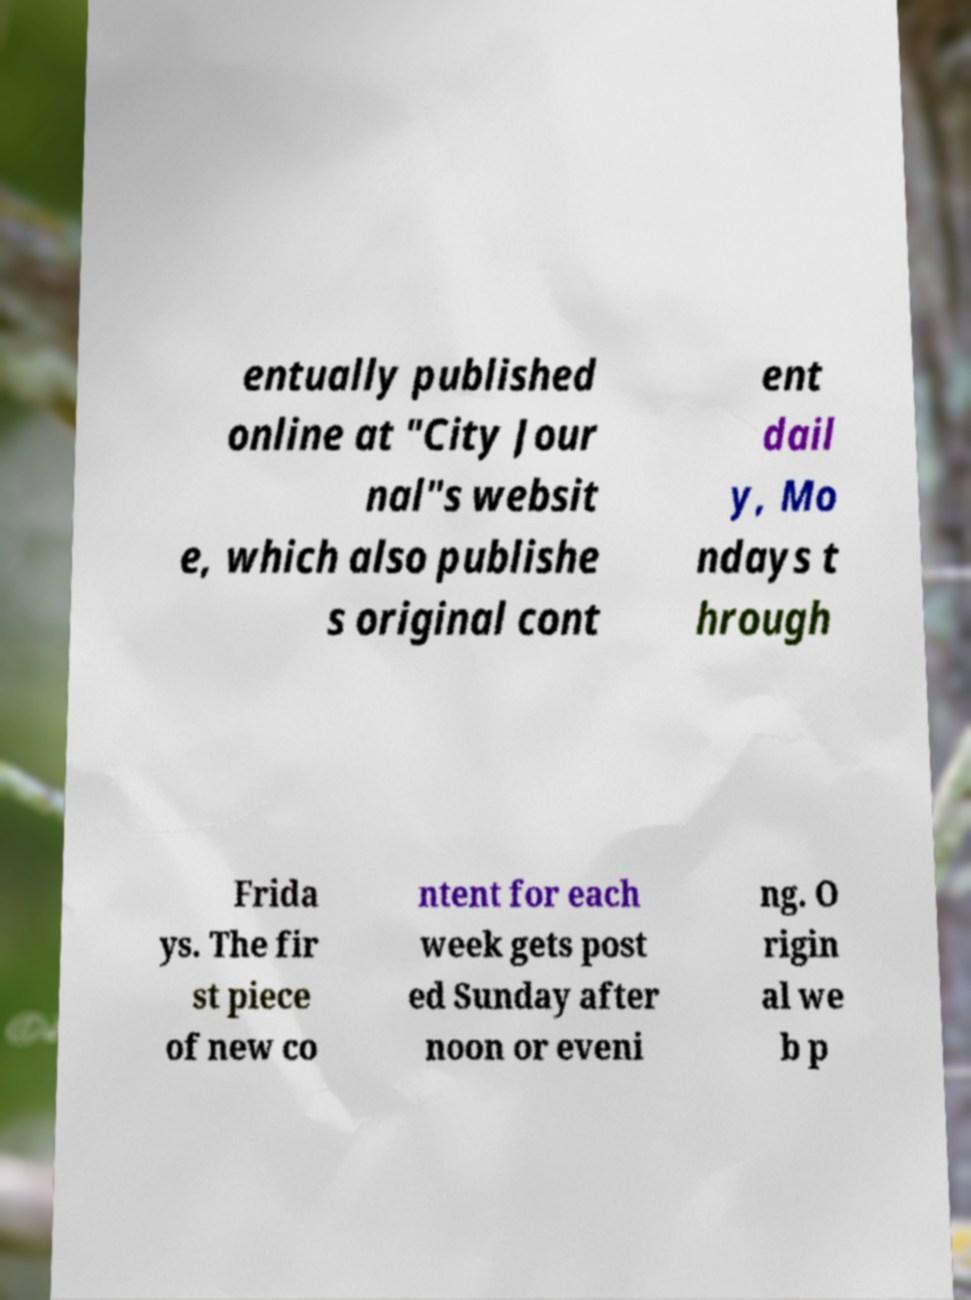Can you accurately transcribe the text from the provided image for me? entually published online at "City Jour nal"s websit e, which also publishe s original cont ent dail y, Mo ndays t hrough Frida ys. The fir st piece of new co ntent for each week gets post ed Sunday after noon or eveni ng. O rigin al we b p 